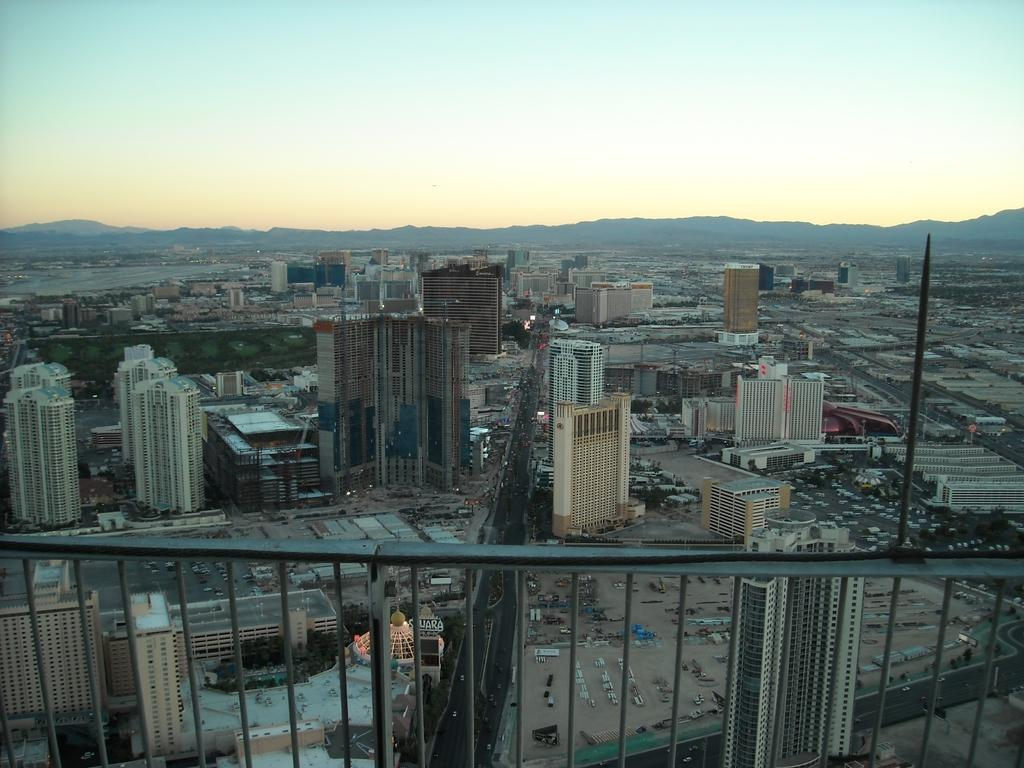What type of structures can be seen in the image? There are buildings in the image. What is located at the bottom of the image? There is a railing at the bottom of the image. What can be seen in the distance in the image? Hills are visible in the background of the image. What else is visible in the background of the image? The sky is visible in the background of the image. How many cows are causing trouble in the image? There are no cows present in the image, nor is there any indication of trouble. 